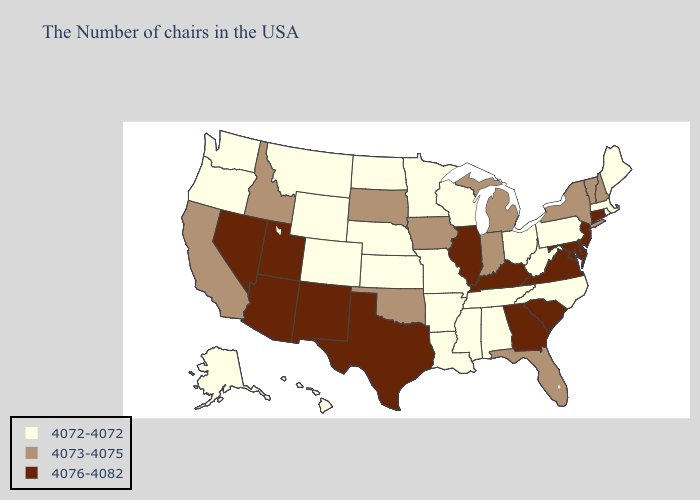Does Maine have the highest value in the USA?
Concise answer only. No. Which states have the lowest value in the Northeast?
Short answer required. Maine, Massachusetts, Rhode Island, Pennsylvania. What is the highest value in the South ?
Answer briefly. 4076-4082. Name the states that have a value in the range 4076-4082?
Short answer required. Connecticut, New Jersey, Delaware, Maryland, Virginia, South Carolina, Georgia, Kentucky, Illinois, Texas, New Mexico, Utah, Arizona, Nevada. Name the states that have a value in the range 4076-4082?
Write a very short answer. Connecticut, New Jersey, Delaware, Maryland, Virginia, South Carolina, Georgia, Kentucky, Illinois, Texas, New Mexico, Utah, Arizona, Nevada. What is the value of Massachusetts?
Answer briefly. 4072-4072. What is the value of Texas?
Give a very brief answer. 4076-4082. Name the states that have a value in the range 4073-4075?
Concise answer only. New Hampshire, Vermont, New York, Florida, Michigan, Indiana, Iowa, Oklahoma, South Dakota, Idaho, California. What is the value of Minnesota?
Answer briefly. 4072-4072. Is the legend a continuous bar?
Keep it brief. No. Does New Mexico have the highest value in the USA?
Be succinct. Yes. What is the highest value in states that border Florida?
Quick response, please. 4076-4082. Name the states that have a value in the range 4076-4082?
Write a very short answer. Connecticut, New Jersey, Delaware, Maryland, Virginia, South Carolina, Georgia, Kentucky, Illinois, Texas, New Mexico, Utah, Arizona, Nevada. Among the states that border Mississippi , which have the lowest value?
Give a very brief answer. Alabama, Tennessee, Louisiana, Arkansas. Does Wyoming have the same value as Massachusetts?
Be succinct. Yes. 